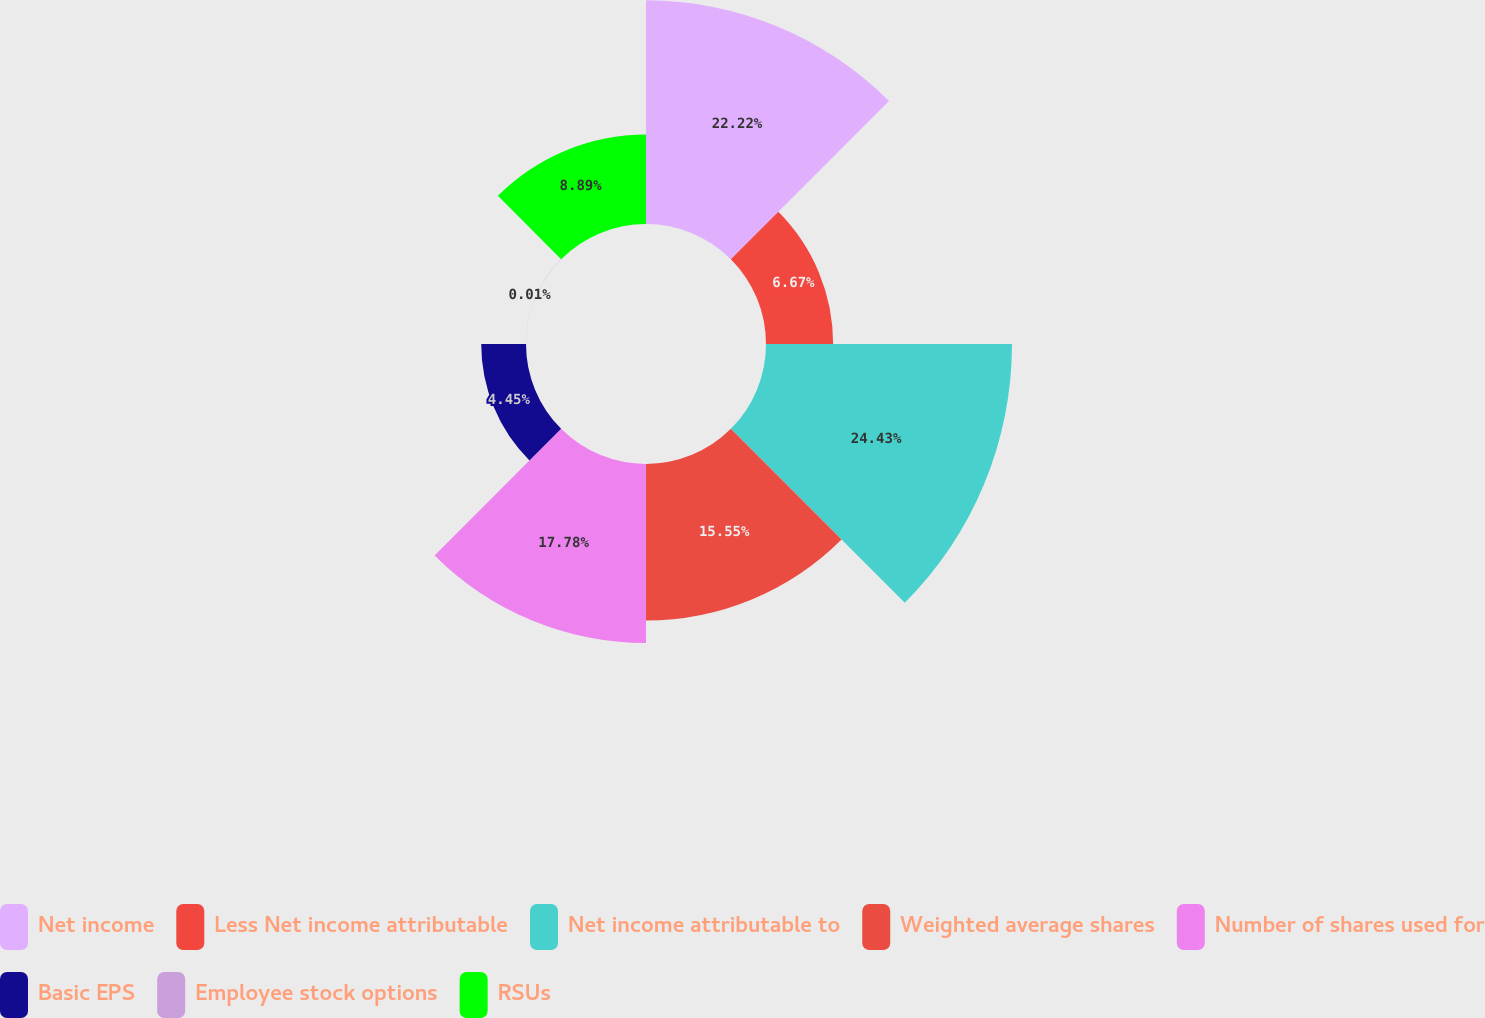Convert chart to OTSL. <chart><loc_0><loc_0><loc_500><loc_500><pie_chart><fcel>Net income<fcel>Less Net income attributable<fcel>Net income attributable to<fcel>Weighted average shares<fcel>Number of shares used for<fcel>Basic EPS<fcel>Employee stock options<fcel>RSUs<nl><fcel>22.22%<fcel>6.67%<fcel>24.44%<fcel>15.55%<fcel>17.78%<fcel>4.45%<fcel>0.01%<fcel>8.89%<nl></chart> 